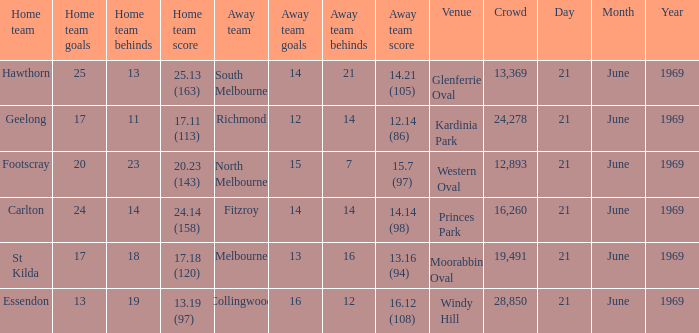When was there a game at Kardinia Park? 21 June 1969. Help me parse the entirety of this table. {'header': ['Home team', 'Home team goals', 'Home team behinds', 'Home team score', 'Away team', 'Away team goals', 'Away team behinds', 'Away team score', 'Venue', 'Crowd', 'Day', 'Month', 'Year'], 'rows': [['Hawthorn', '25', '13', '25.13 (163)', 'South Melbourne', '14', '21', '14.21 (105)', 'Glenferrie Oval', '13,369', '21', 'June', '1969'], ['Geelong', '17', '11', '17.11 (113)', 'Richmond', '12', '14', '12.14 (86)', 'Kardinia Park', '24,278', '21', 'June', '1969'], ['Footscray', '20', '23', '20.23 (143)', 'North Melbourne', '15', '7', '15.7 (97)', 'Western Oval', '12,893', '21', 'June', '1969'], ['Carlton', '24', '14', '24.14 (158)', 'Fitzroy', '14', '14', '14.14 (98)', 'Princes Park', '16,260', '21', 'June', '1969'], ['St Kilda', '17', '18', '17.18 (120)', 'Melbourne', '13', '16', '13.16 (94)', 'Moorabbin Oval', '19,491', '21', 'June', '1969'], ['Essendon', '13', '19', '13.19 (97)', 'Collingwood', '16', '12', '16.12 (108)', 'Windy Hill', '28,850', '21', 'June', '1969']]} 